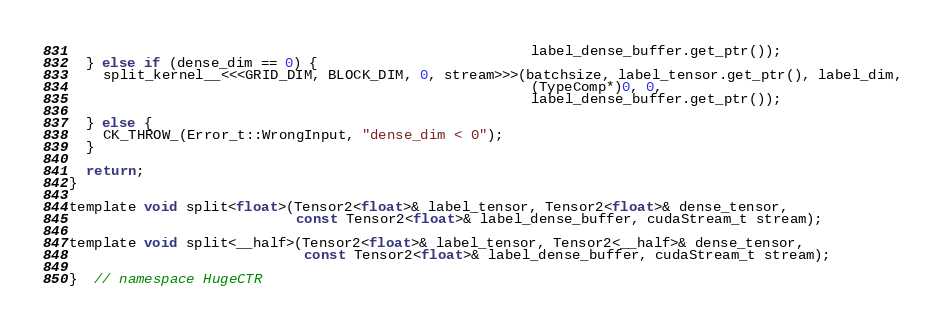Convert code to text. <code><loc_0><loc_0><loc_500><loc_500><_Cuda_>                                                       label_dense_buffer.get_ptr());
  } else if (dense_dim == 0) {
    split_kernel__<<<GRID_DIM, BLOCK_DIM, 0, stream>>>(batchsize, label_tensor.get_ptr(), label_dim,
                                                       (TypeComp*)0, 0,
                                                       label_dense_buffer.get_ptr());

  } else {
    CK_THROW_(Error_t::WrongInput, "dense_dim < 0");
  }

  return;
}

template void split<float>(Tensor2<float>& label_tensor, Tensor2<float>& dense_tensor,
                           const Tensor2<float>& label_dense_buffer, cudaStream_t stream);

template void split<__half>(Tensor2<float>& label_tensor, Tensor2<__half>& dense_tensor,
                            const Tensor2<float>& label_dense_buffer, cudaStream_t stream);

}  // namespace HugeCTR
</code> 